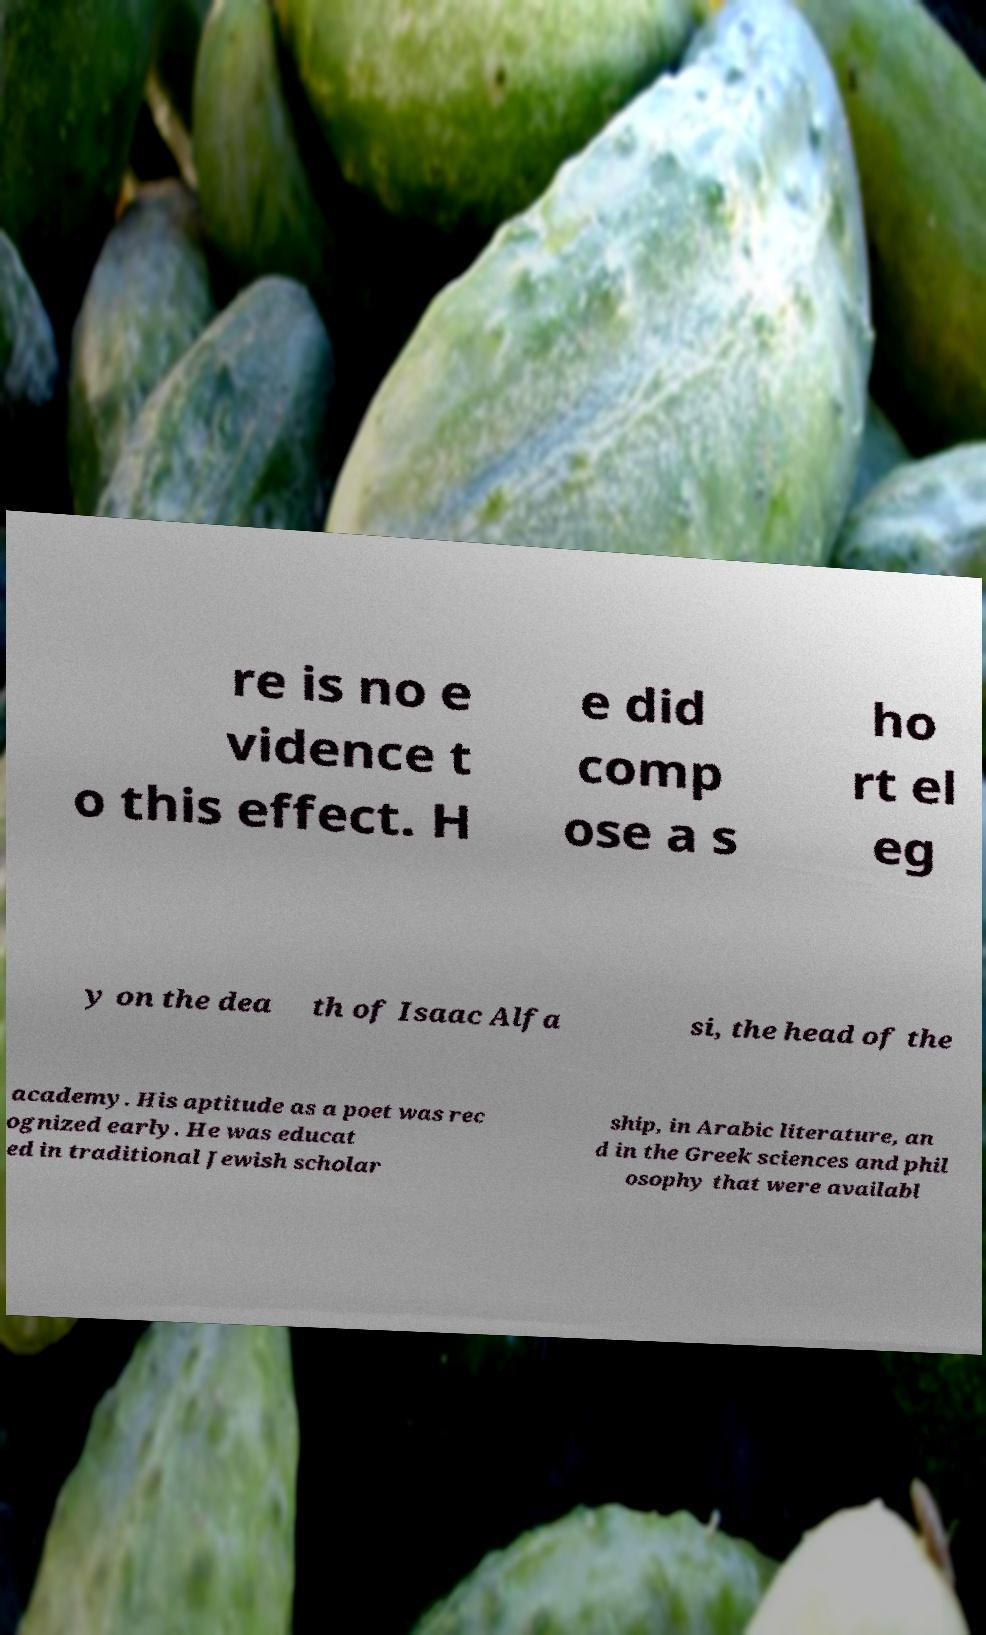What messages or text are displayed in this image? I need them in a readable, typed format. re is no e vidence t o this effect. H e did comp ose a s ho rt el eg y on the dea th of Isaac Alfa si, the head of the academy. His aptitude as a poet was rec ognized early. He was educat ed in traditional Jewish scholar ship, in Arabic literature, an d in the Greek sciences and phil osophy that were availabl 